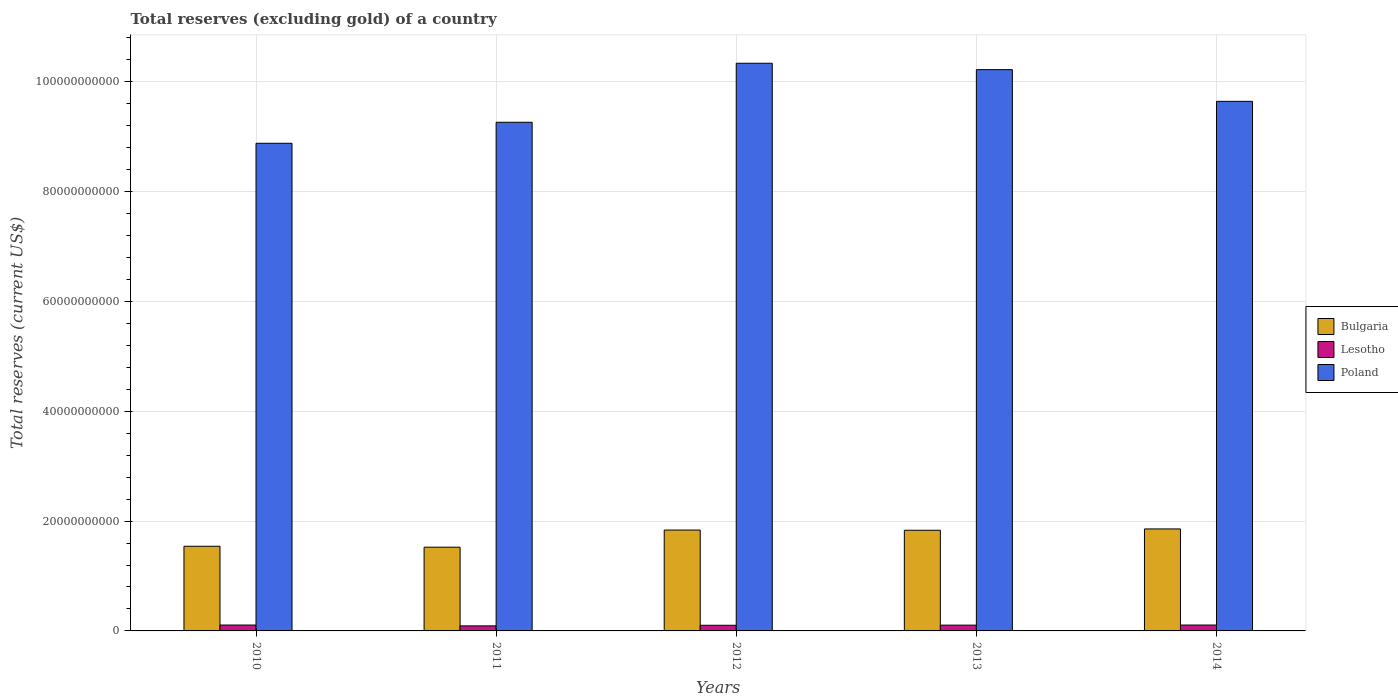How many different coloured bars are there?
Your answer should be compact. 3. How many groups of bars are there?
Your answer should be very brief. 5. Are the number of bars on each tick of the X-axis equal?
Give a very brief answer. Yes. How many bars are there on the 5th tick from the right?
Offer a very short reply. 3. What is the label of the 4th group of bars from the left?
Your response must be concise. 2013. In how many cases, is the number of bars for a given year not equal to the number of legend labels?
Your response must be concise. 0. What is the total reserves (excluding gold) in Lesotho in 2012?
Your response must be concise. 1.03e+09. Across all years, what is the maximum total reserves (excluding gold) in Bulgaria?
Provide a short and direct response. 1.86e+1. Across all years, what is the minimum total reserves (excluding gold) in Lesotho?
Offer a very short reply. 9.19e+08. In which year was the total reserves (excluding gold) in Bulgaria maximum?
Your answer should be compact. 2014. In which year was the total reserves (excluding gold) in Poland minimum?
Keep it short and to the point. 2010. What is the total total reserves (excluding gold) in Poland in the graph?
Provide a succinct answer. 4.84e+11. What is the difference between the total reserves (excluding gold) in Poland in 2011 and that in 2012?
Give a very brief answer. -1.07e+1. What is the difference between the total reserves (excluding gold) in Poland in 2010 and the total reserves (excluding gold) in Bulgaria in 2012?
Ensure brevity in your answer.  7.05e+1. What is the average total reserves (excluding gold) in Poland per year?
Provide a succinct answer. 9.67e+1. In the year 2013, what is the difference between the total reserves (excluding gold) in Bulgaria and total reserves (excluding gold) in Poland?
Offer a terse response. -8.39e+1. What is the ratio of the total reserves (excluding gold) in Bulgaria in 2010 to that in 2012?
Make the answer very short. 0.84. What is the difference between the highest and the second highest total reserves (excluding gold) in Poland?
Ensure brevity in your answer.  1.16e+09. What is the difference between the highest and the lowest total reserves (excluding gold) in Bulgaria?
Your answer should be compact. 3.32e+09. What does the 3rd bar from the left in 2011 represents?
Your response must be concise. Poland. What does the 1st bar from the right in 2013 represents?
Offer a terse response. Poland. What is the difference between two consecutive major ticks on the Y-axis?
Ensure brevity in your answer.  2.00e+1. Does the graph contain any zero values?
Give a very brief answer. No. Does the graph contain grids?
Keep it short and to the point. Yes. How many legend labels are there?
Provide a short and direct response. 3. How are the legend labels stacked?
Keep it short and to the point. Vertical. What is the title of the graph?
Provide a short and direct response. Total reserves (excluding gold) of a country. What is the label or title of the Y-axis?
Make the answer very short. Total reserves (current US$). What is the Total reserves (current US$) of Bulgaria in 2010?
Your response must be concise. 1.54e+1. What is the Total reserves (current US$) of Lesotho in 2010?
Offer a terse response. 1.07e+09. What is the Total reserves (current US$) in Poland in 2010?
Give a very brief answer. 8.88e+1. What is the Total reserves (current US$) of Bulgaria in 2011?
Keep it short and to the point. 1.53e+1. What is the Total reserves (current US$) of Lesotho in 2011?
Provide a short and direct response. 9.19e+08. What is the Total reserves (current US$) of Poland in 2011?
Make the answer very short. 9.26e+1. What is the Total reserves (current US$) in Bulgaria in 2012?
Your answer should be compact. 1.84e+1. What is the Total reserves (current US$) in Lesotho in 2012?
Offer a very short reply. 1.03e+09. What is the Total reserves (current US$) of Poland in 2012?
Your response must be concise. 1.03e+11. What is the Total reserves (current US$) in Bulgaria in 2013?
Give a very brief answer. 1.83e+1. What is the Total reserves (current US$) in Lesotho in 2013?
Your answer should be very brief. 1.06e+09. What is the Total reserves (current US$) of Poland in 2013?
Your response must be concise. 1.02e+11. What is the Total reserves (current US$) in Bulgaria in 2014?
Provide a succinct answer. 1.86e+1. What is the Total reserves (current US$) of Lesotho in 2014?
Offer a very short reply. 1.07e+09. What is the Total reserves (current US$) in Poland in 2014?
Provide a succinct answer. 9.65e+1. Across all years, what is the maximum Total reserves (current US$) in Bulgaria?
Your answer should be compact. 1.86e+1. Across all years, what is the maximum Total reserves (current US$) in Lesotho?
Ensure brevity in your answer.  1.07e+09. Across all years, what is the maximum Total reserves (current US$) of Poland?
Your answer should be compact. 1.03e+11. Across all years, what is the minimum Total reserves (current US$) in Bulgaria?
Provide a short and direct response. 1.53e+1. Across all years, what is the minimum Total reserves (current US$) in Lesotho?
Keep it short and to the point. 9.19e+08. Across all years, what is the minimum Total reserves (current US$) in Poland?
Give a very brief answer. 8.88e+1. What is the total Total reserves (current US$) in Bulgaria in the graph?
Your answer should be very brief. 8.60e+1. What is the total Total reserves (current US$) of Lesotho in the graph?
Your answer should be compact. 5.14e+09. What is the total Total reserves (current US$) of Poland in the graph?
Give a very brief answer. 4.84e+11. What is the difference between the Total reserves (current US$) in Bulgaria in 2010 and that in 2011?
Give a very brief answer. 1.69e+08. What is the difference between the Total reserves (current US$) of Lesotho in 2010 and that in 2011?
Ensure brevity in your answer.  1.52e+08. What is the difference between the Total reserves (current US$) in Poland in 2010 and that in 2011?
Offer a terse response. -3.82e+09. What is the difference between the Total reserves (current US$) in Bulgaria in 2010 and that in 2012?
Provide a succinct answer. -2.95e+09. What is the difference between the Total reserves (current US$) in Lesotho in 2010 and that in 2012?
Your answer should be very brief. 4.30e+07. What is the difference between the Total reserves (current US$) of Poland in 2010 and that in 2012?
Ensure brevity in your answer.  -1.46e+1. What is the difference between the Total reserves (current US$) in Bulgaria in 2010 and that in 2013?
Provide a short and direct response. -2.91e+09. What is the difference between the Total reserves (current US$) in Lesotho in 2010 and that in 2013?
Your response must be concise. 1.57e+07. What is the difference between the Total reserves (current US$) of Poland in 2010 and that in 2013?
Offer a very short reply. -1.34e+1. What is the difference between the Total reserves (current US$) of Bulgaria in 2010 and that in 2014?
Keep it short and to the point. -3.16e+09. What is the difference between the Total reserves (current US$) in Lesotho in 2010 and that in 2014?
Offer a terse response. 1.25e+05. What is the difference between the Total reserves (current US$) in Poland in 2010 and that in 2014?
Your answer should be very brief. -7.64e+09. What is the difference between the Total reserves (current US$) in Bulgaria in 2011 and that in 2012?
Your answer should be very brief. -3.12e+09. What is the difference between the Total reserves (current US$) in Lesotho in 2011 and that in 2012?
Provide a succinct answer. -1.09e+08. What is the difference between the Total reserves (current US$) of Poland in 2011 and that in 2012?
Make the answer very short. -1.07e+1. What is the difference between the Total reserves (current US$) in Bulgaria in 2011 and that in 2013?
Give a very brief answer. -3.08e+09. What is the difference between the Total reserves (current US$) in Lesotho in 2011 and that in 2013?
Your answer should be very brief. -1.36e+08. What is the difference between the Total reserves (current US$) in Poland in 2011 and that in 2013?
Your answer should be very brief. -9.59e+09. What is the difference between the Total reserves (current US$) in Bulgaria in 2011 and that in 2014?
Make the answer very short. -3.32e+09. What is the difference between the Total reserves (current US$) in Lesotho in 2011 and that in 2014?
Make the answer very short. -1.52e+08. What is the difference between the Total reserves (current US$) of Poland in 2011 and that in 2014?
Your answer should be very brief. -3.82e+09. What is the difference between the Total reserves (current US$) of Bulgaria in 2012 and that in 2013?
Provide a short and direct response. 3.63e+07. What is the difference between the Total reserves (current US$) in Lesotho in 2012 and that in 2013?
Offer a terse response. -2.73e+07. What is the difference between the Total reserves (current US$) in Poland in 2012 and that in 2013?
Offer a very short reply. 1.16e+09. What is the difference between the Total reserves (current US$) of Bulgaria in 2012 and that in 2014?
Offer a terse response. -2.05e+08. What is the difference between the Total reserves (current US$) of Lesotho in 2012 and that in 2014?
Keep it short and to the point. -4.29e+07. What is the difference between the Total reserves (current US$) of Poland in 2012 and that in 2014?
Keep it short and to the point. 6.93e+09. What is the difference between the Total reserves (current US$) of Bulgaria in 2013 and that in 2014?
Your answer should be compact. -2.41e+08. What is the difference between the Total reserves (current US$) of Lesotho in 2013 and that in 2014?
Provide a succinct answer. -1.56e+07. What is the difference between the Total reserves (current US$) in Poland in 2013 and that in 2014?
Make the answer very short. 5.77e+09. What is the difference between the Total reserves (current US$) of Bulgaria in 2010 and the Total reserves (current US$) of Lesotho in 2011?
Your response must be concise. 1.45e+1. What is the difference between the Total reserves (current US$) of Bulgaria in 2010 and the Total reserves (current US$) of Poland in 2011?
Your answer should be very brief. -7.72e+1. What is the difference between the Total reserves (current US$) in Lesotho in 2010 and the Total reserves (current US$) in Poland in 2011?
Provide a short and direct response. -9.16e+1. What is the difference between the Total reserves (current US$) in Bulgaria in 2010 and the Total reserves (current US$) in Lesotho in 2012?
Ensure brevity in your answer.  1.44e+1. What is the difference between the Total reserves (current US$) of Bulgaria in 2010 and the Total reserves (current US$) of Poland in 2012?
Offer a very short reply. -8.80e+1. What is the difference between the Total reserves (current US$) in Lesotho in 2010 and the Total reserves (current US$) in Poland in 2012?
Provide a succinct answer. -1.02e+11. What is the difference between the Total reserves (current US$) in Bulgaria in 2010 and the Total reserves (current US$) in Lesotho in 2013?
Provide a succinct answer. 1.44e+1. What is the difference between the Total reserves (current US$) of Bulgaria in 2010 and the Total reserves (current US$) of Poland in 2013?
Provide a succinct answer. -8.68e+1. What is the difference between the Total reserves (current US$) in Lesotho in 2010 and the Total reserves (current US$) in Poland in 2013?
Provide a short and direct response. -1.01e+11. What is the difference between the Total reserves (current US$) in Bulgaria in 2010 and the Total reserves (current US$) in Lesotho in 2014?
Ensure brevity in your answer.  1.43e+1. What is the difference between the Total reserves (current US$) of Bulgaria in 2010 and the Total reserves (current US$) of Poland in 2014?
Provide a short and direct response. -8.10e+1. What is the difference between the Total reserves (current US$) in Lesotho in 2010 and the Total reserves (current US$) in Poland in 2014?
Your response must be concise. -9.54e+1. What is the difference between the Total reserves (current US$) of Bulgaria in 2011 and the Total reserves (current US$) of Lesotho in 2012?
Offer a very short reply. 1.42e+1. What is the difference between the Total reserves (current US$) of Bulgaria in 2011 and the Total reserves (current US$) of Poland in 2012?
Keep it short and to the point. -8.81e+1. What is the difference between the Total reserves (current US$) of Lesotho in 2011 and the Total reserves (current US$) of Poland in 2012?
Your response must be concise. -1.02e+11. What is the difference between the Total reserves (current US$) of Bulgaria in 2011 and the Total reserves (current US$) of Lesotho in 2013?
Provide a short and direct response. 1.42e+1. What is the difference between the Total reserves (current US$) of Bulgaria in 2011 and the Total reserves (current US$) of Poland in 2013?
Your answer should be very brief. -8.70e+1. What is the difference between the Total reserves (current US$) of Lesotho in 2011 and the Total reserves (current US$) of Poland in 2013?
Make the answer very short. -1.01e+11. What is the difference between the Total reserves (current US$) in Bulgaria in 2011 and the Total reserves (current US$) in Lesotho in 2014?
Provide a short and direct response. 1.42e+1. What is the difference between the Total reserves (current US$) in Bulgaria in 2011 and the Total reserves (current US$) in Poland in 2014?
Offer a terse response. -8.12e+1. What is the difference between the Total reserves (current US$) of Lesotho in 2011 and the Total reserves (current US$) of Poland in 2014?
Provide a short and direct response. -9.55e+1. What is the difference between the Total reserves (current US$) in Bulgaria in 2012 and the Total reserves (current US$) in Lesotho in 2013?
Ensure brevity in your answer.  1.73e+1. What is the difference between the Total reserves (current US$) of Bulgaria in 2012 and the Total reserves (current US$) of Poland in 2013?
Ensure brevity in your answer.  -8.39e+1. What is the difference between the Total reserves (current US$) in Lesotho in 2012 and the Total reserves (current US$) in Poland in 2013?
Provide a succinct answer. -1.01e+11. What is the difference between the Total reserves (current US$) of Bulgaria in 2012 and the Total reserves (current US$) of Lesotho in 2014?
Keep it short and to the point. 1.73e+1. What is the difference between the Total reserves (current US$) of Bulgaria in 2012 and the Total reserves (current US$) of Poland in 2014?
Give a very brief answer. -7.81e+1. What is the difference between the Total reserves (current US$) in Lesotho in 2012 and the Total reserves (current US$) in Poland in 2014?
Offer a very short reply. -9.54e+1. What is the difference between the Total reserves (current US$) of Bulgaria in 2013 and the Total reserves (current US$) of Lesotho in 2014?
Your answer should be compact. 1.73e+1. What is the difference between the Total reserves (current US$) of Bulgaria in 2013 and the Total reserves (current US$) of Poland in 2014?
Your answer should be compact. -7.81e+1. What is the difference between the Total reserves (current US$) in Lesotho in 2013 and the Total reserves (current US$) in Poland in 2014?
Provide a succinct answer. -9.54e+1. What is the average Total reserves (current US$) in Bulgaria per year?
Provide a short and direct response. 1.72e+1. What is the average Total reserves (current US$) in Lesotho per year?
Your answer should be very brief. 1.03e+09. What is the average Total reserves (current US$) in Poland per year?
Offer a very short reply. 9.67e+1. In the year 2010, what is the difference between the Total reserves (current US$) in Bulgaria and Total reserves (current US$) in Lesotho?
Offer a very short reply. 1.43e+1. In the year 2010, what is the difference between the Total reserves (current US$) of Bulgaria and Total reserves (current US$) of Poland?
Give a very brief answer. -7.34e+1. In the year 2010, what is the difference between the Total reserves (current US$) of Lesotho and Total reserves (current US$) of Poland?
Offer a very short reply. -8.78e+1. In the year 2011, what is the difference between the Total reserves (current US$) in Bulgaria and Total reserves (current US$) in Lesotho?
Provide a succinct answer. 1.43e+1. In the year 2011, what is the difference between the Total reserves (current US$) in Bulgaria and Total reserves (current US$) in Poland?
Provide a succinct answer. -7.74e+1. In the year 2011, what is the difference between the Total reserves (current US$) of Lesotho and Total reserves (current US$) of Poland?
Make the answer very short. -9.17e+1. In the year 2012, what is the difference between the Total reserves (current US$) of Bulgaria and Total reserves (current US$) of Lesotho?
Offer a terse response. 1.73e+1. In the year 2012, what is the difference between the Total reserves (current US$) in Bulgaria and Total reserves (current US$) in Poland?
Make the answer very short. -8.50e+1. In the year 2012, what is the difference between the Total reserves (current US$) in Lesotho and Total reserves (current US$) in Poland?
Your answer should be very brief. -1.02e+11. In the year 2013, what is the difference between the Total reserves (current US$) in Bulgaria and Total reserves (current US$) in Lesotho?
Ensure brevity in your answer.  1.73e+1. In the year 2013, what is the difference between the Total reserves (current US$) of Bulgaria and Total reserves (current US$) of Poland?
Give a very brief answer. -8.39e+1. In the year 2013, what is the difference between the Total reserves (current US$) of Lesotho and Total reserves (current US$) of Poland?
Give a very brief answer. -1.01e+11. In the year 2014, what is the difference between the Total reserves (current US$) of Bulgaria and Total reserves (current US$) of Lesotho?
Give a very brief answer. 1.75e+1. In the year 2014, what is the difference between the Total reserves (current US$) in Bulgaria and Total reserves (current US$) in Poland?
Provide a succinct answer. -7.79e+1. In the year 2014, what is the difference between the Total reserves (current US$) in Lesotho and Total reserves (current US$) in Poland?
Offer a terse response. -9.54e+1. What is the ratio of the Total reserves (current US$) in Bulgaria in 2010 to that in 2011?
Provide a succinct answer. 1.01. What is the ratio of the Total reserves (current US$) in Lesotho in 2010 to that in 2011?
Offer a very short reply. 1.17. What is the ratio of the Total reserves (current US$) of Poland in 2010 to that in 2011?
Give a very brief answer. 0.96. What is the ratio of the Total reserves (current US$) of Bulgaria in 2010 to that in 2012?
Your answer should be compact. 0.84. What is the ratio of the Total reserves (current US$) in Lesotho in 2010 to that in 2012?
Provide a short and direct response. 1.04. What is the ratio of the Total reserves (current US$) of Poland in 2010 to that in 2012?
Make the answer very short. 0.86. What is the ratio of the Total reserves (current US$) in Bulgaria in 2010 to that in 2013?
Offer a terse response. 0.84. What is the ratio of the Total reserves (current US$) of Lesotho in 2010 to that in 2013?
Provide a succinct answer. 1.01. What is the ratio of the Total reserves (current US$) of Poland in 2010 to that in 2013?
Make the answer very short. 0.87. What is the ratio of the Total reserves (current US$) in Bulgaria in 2010 to that in 2014?
Offer a terse response. 0.83. What is the ratio of the Total reserves (current US$) in Lesotho in 2010 to that in 2014?
Offer a terse response. 1. What is the ratio of the Total reserves (current US$) of Poland in 2010 to that in 2014?
Provide a short and direct response. 0.92. What is the ratio of the Total reserves (current US$) of Bulgaria in 2011 to that in 2012?
Make the answer very short. 0.83. What is the ratio of the Total reserves (current US$) in Lesotho in 2011 to that in 2012?
Provide a succinct answer. 0.89. What is the ratio of the Total reserves (current US$) of Poland in 2011 to that in 2012?
Provide a short and direct response. 0.9. What is the ratio of the Total reserves (current US$) of Bulgaria in 2011 to that in 2013?
Your response must be concise. 0.83. What is the ratio of the Total reserves (current US$) of Lesotho in 2011 to that in 2013?
Your answer should be compact. 0.87. What is the ratio of the Total reserves (current US$) in Poland in 2011 to that in 2013?
Keep it short and to the point. 0.91. What is the ratio of the Total reserves (current US$) in Bulgaria in 2011 to that in 2014?
Your answer should be very brief. 0.82. What is the ratio of the Total reserves (current US$) in Lesotho in 2011 to that in 2014?
Provide a succinct answer. 0.86. What is the ratio of the Total reserves (current US$) of Poland in 2011 to that in 2014?
Offer a very short reply. 0.96. What is the ratio of the Total reserves (current US$) in Bulgaria in 2012 to that in 2013?
Offer a terse response. 1. What is the ratio of the Total reserves (current US$) in Lesotho in 2012 to that in 2013?
Your answer should be compact. 0.97. What is the ratio of the Total reserves (current US$) in Poland in 2012 to that in 2013?
Your answer should be compact. 1.01. What is the ratio of the Total reserves (current US$) of Lesotho in 2012 to that in 2014?
Your response must be concise. 0.96. What is the ratio of the Total reserves (current US$) in Poland in 2012 to that in 2014?
Your response must be concise. 1.07. What is the ratio of the Total reserves (current US$) in Lesotho in 2013 to that in 2014?
Keep it short and to the point. 0.99. What is the ratio of the Total reserves (current US$) in Poland in 2013 to that in 2014?
Your response must be concise. 1.06. What is the difference between the highest and the second highest Total reserves (current US$) of Bulgaria?
Provide a succinct answer. 2.05e+08. What is the difference between the highest and the second highest Total reserves (current US$) in Lesotho?
Ensure brevity in your answer.  1.25e+05. What is the difference between the highest and the second highest Total reserves (current US$) in Poland?
Your answer should be very brief. 1.16e+09. What is the difference between the highest and the lowest Total reserves (current US$) of Bulgaria?
Keep it short and to the point. 3.32e+09. What is the difference between the highest and the lowest Total reserves (current US$) of Lesotho?
Your answer should be compact. 1.52e+08. What is the difference between the highest and the lowest Total reserves (current US$) in Poland?
Keep it short and to the point. 1.46e+1. 